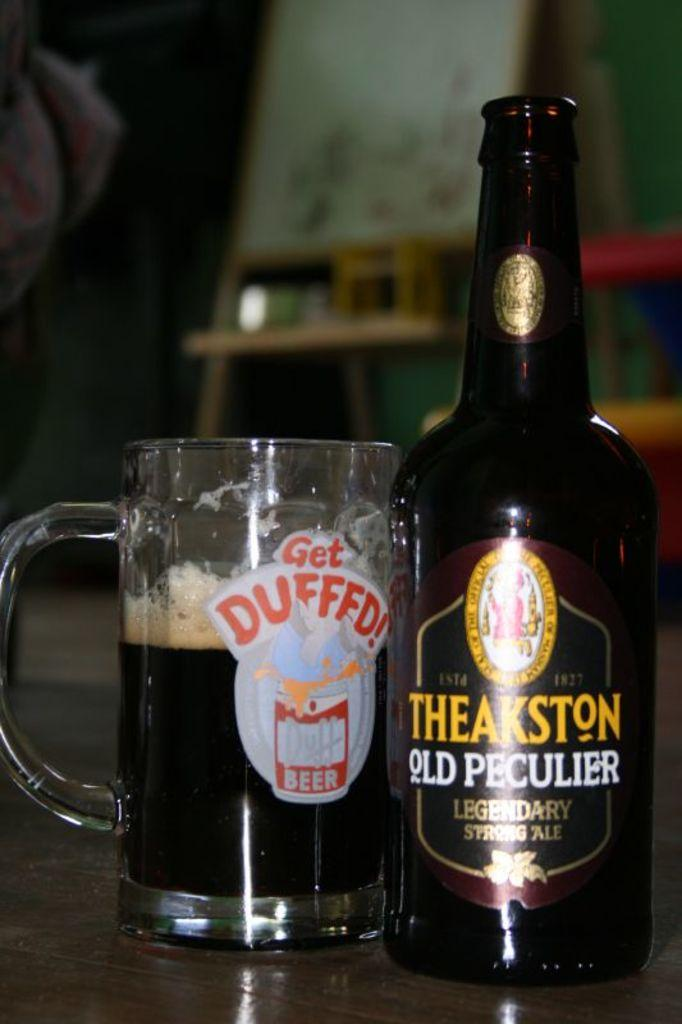<image>
Describe the image concisely. A Theakston brand bottle is next to a mug that is half full. 